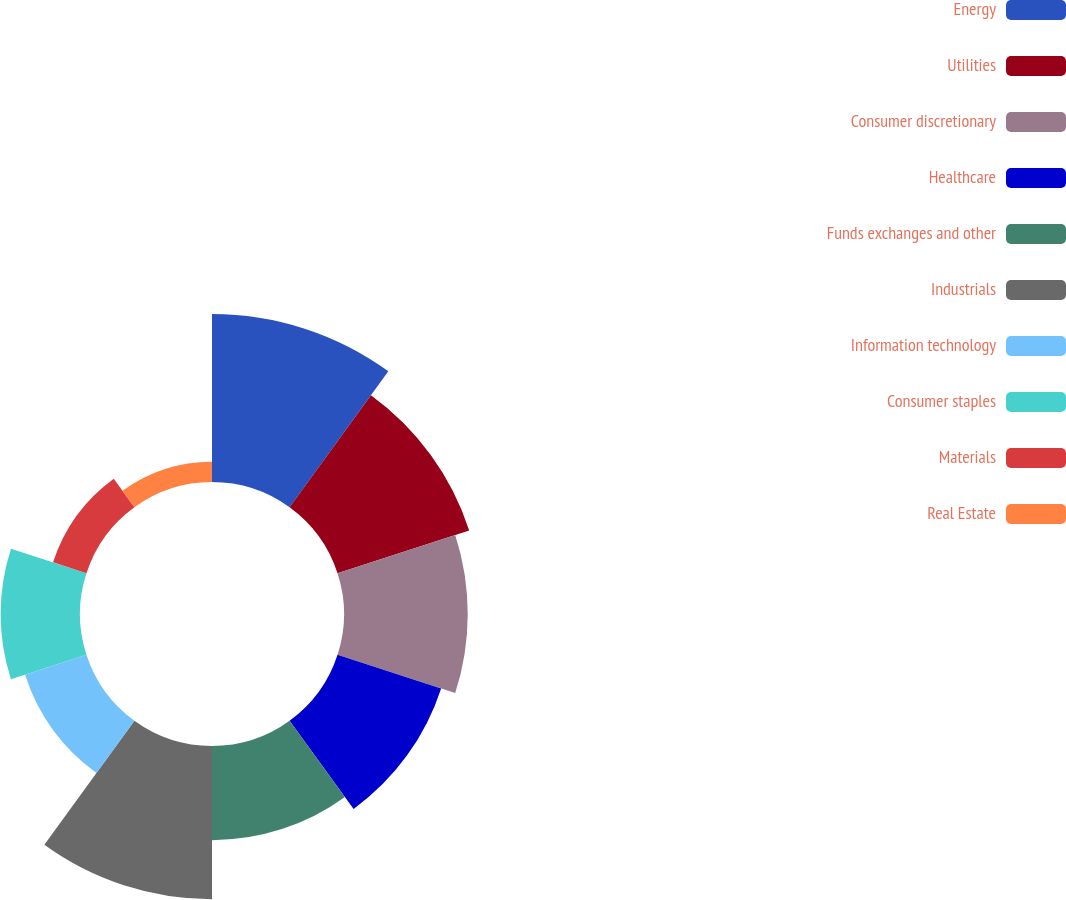Convert chart to OTSL. <chart><loc_0><loc_0><loc_500><loc_500><pie_chart><fcel>Energy<fcel>Utilities<fcel>Consumer discretionary<fcel>Healthcare<fcel>Funds exchanges and other<fcel>Industrials<fcel>Information technology<fcel>Consumer staples<fcel>Materials<fcel>Real Estate<nl><fcel>17.04%<fcel>14.04%<fcel>12.55%<fcel>11.05%<fcel>9.55%<fcel>15.54%<fcel>6.55%<fcel>8.05%<fcel>3.56%<fcel>2.06%<nl></chart> 